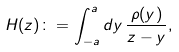Convert formula to latex. <formula><loc_0><loc_0><loc_500><loc_500>H ( z ) \colon = \int _ { - a } ^ { a } d y \, \frac { \rho ( y ) } { z - y } ,</formula> 